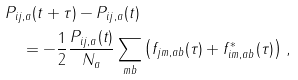<formula> <loc_0><loc_0><loc_500><loc_500>& P _ { i j , a } ( t + \tau ) - P _ { i j , a } ( t ) \\ & \quad = - \frac { 1 } { 2 } \frac { P _ { i j , a } ( t ) } { N _ { a } } \sum _ { m b } \left ( f _ { j m , a b } ( \tau ) + f ^ { * } _ { i m , a b } ( \tau ) \right ) \, ,</formula> 